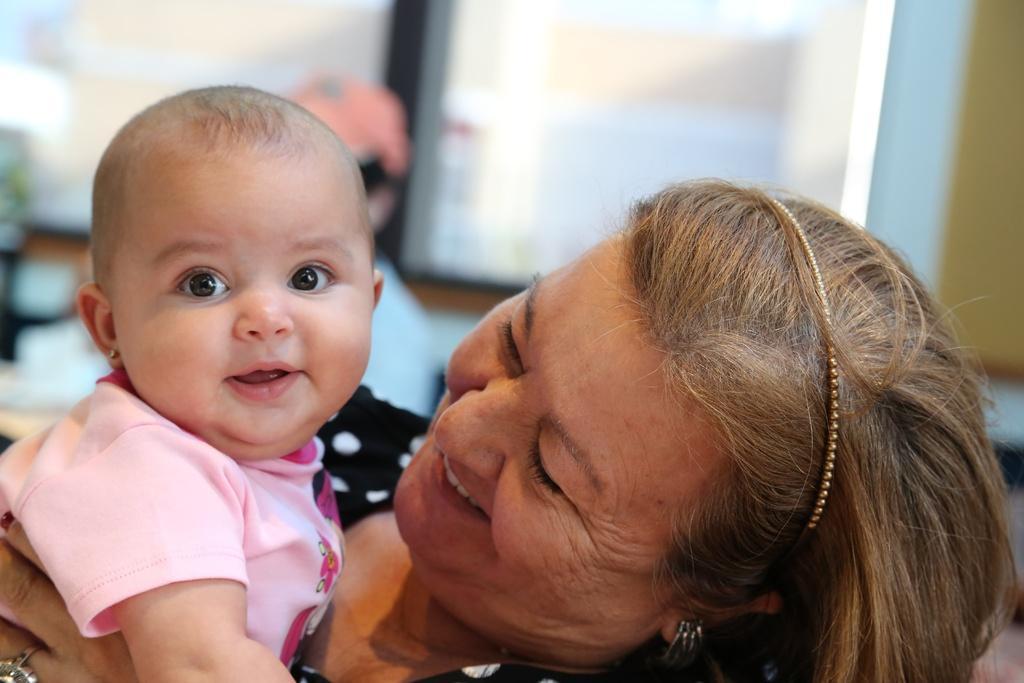In one or two sentences, can you explain what this image depicts? In this picture, we can see a few people and the blurred background. 